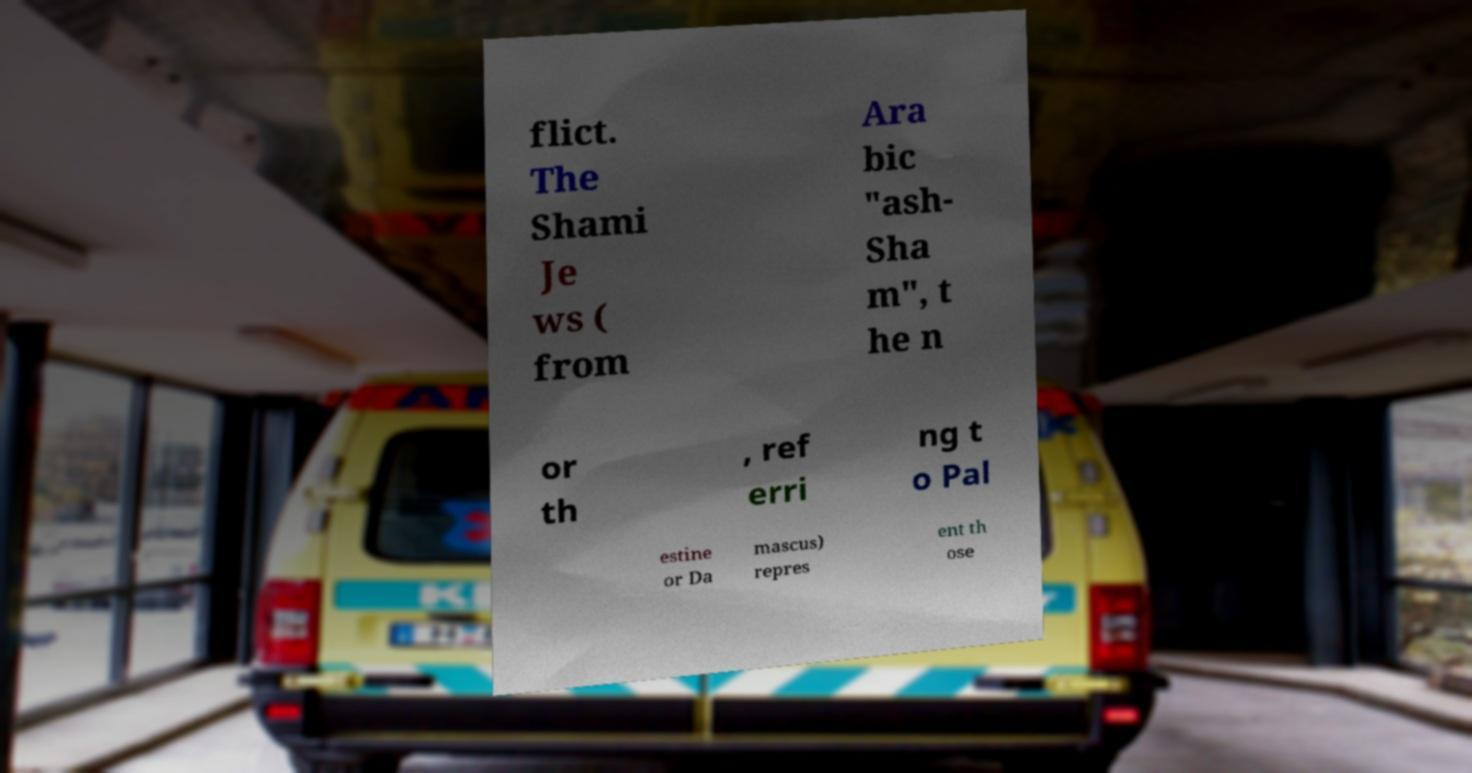Please identify and transcribe the text found in this image. flict. The Shami Je ws ( from Ara bic "ash- Sha m", t he n or th , ref erri ng t o Pal estine or Da mascus) repres ent th ose 